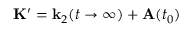<formula> <loc_0><loc_0><loc_500><loc_500>K ^ { \prime } = k _ { 2 } ( t \rightarrow \infty ) + A ( t _ { 0 } )</formula> 